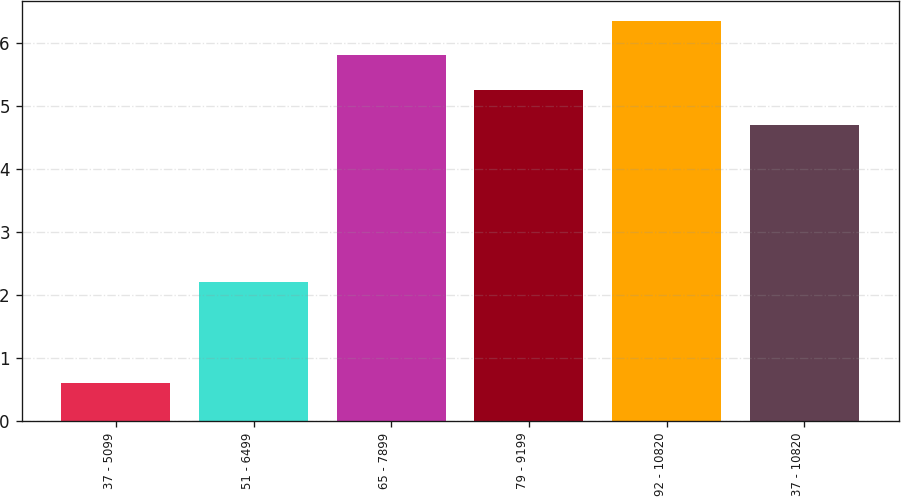Convert chart. <chart><loc_0><loc_0><loc_500><loc_500><bar_chart><fcel>37 - 5099<fcel>51 - 6499<fcel>65 - 7899<fcel>79 - 9199<fcel>92 - 10820<fcel>37 - 10820<nl><fcel>0.6<fcel>2.2<fcel>5.8<fcel>5.25<fcel>6.35<fcel>4.7<nl></chart> 